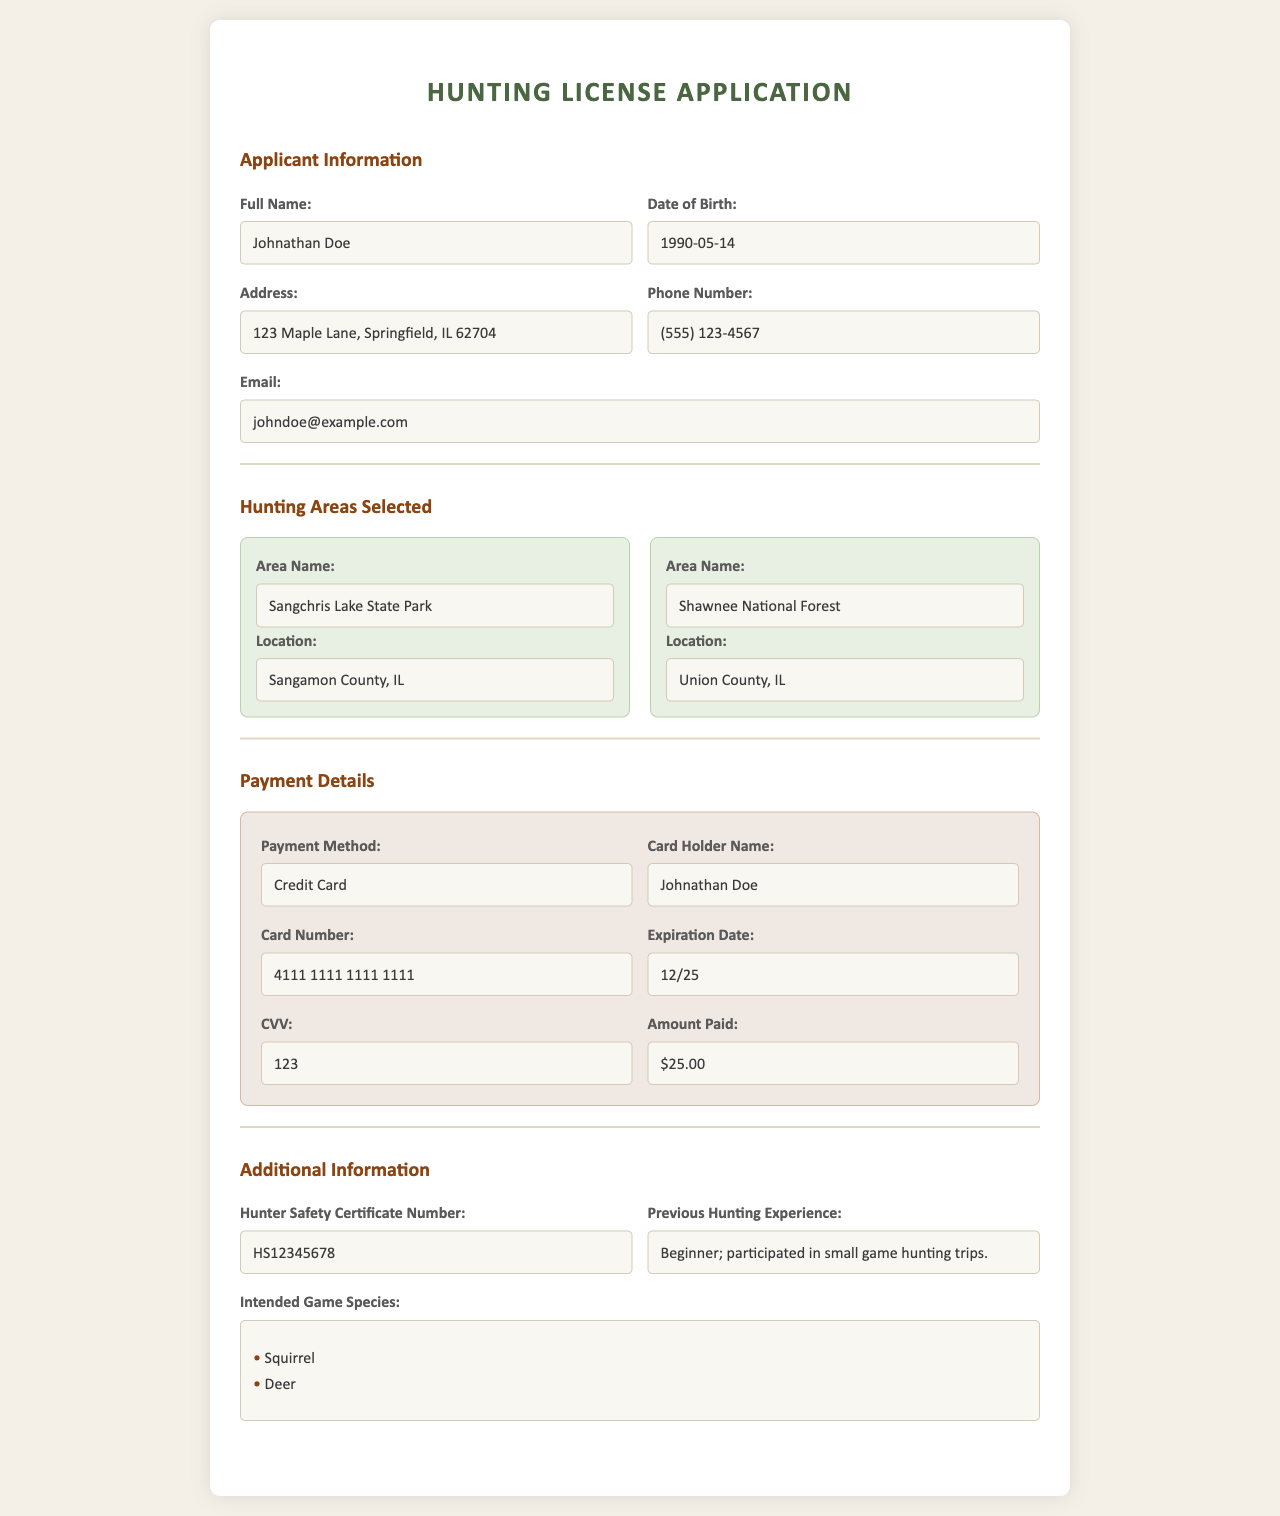What is the applicant's full name? The full name of the applicant is provided in the document under "Applicant Information."
Answer: Johnathan Doe What is the applicant's date of birth? The date of birth is specified in the "Applicant Information" section.
Answer: 1990-05-14 Which hunting area is located in Sangamon County? The document lists hunting areas selected along with their locations. Sangchris Lake State Park is in Sangamon County.
Answer: Sangchris Lake State Park What is the payment method used for this application? The payment method is mentioned in the "Payment Details" section of the document.
Answer: Credit Card What is the total amount paid for the hunting license? The amount paid is found in the "Amount Paid" section of the "Payment Details."
Answer: $25.00 How many game species are intended to be hunted? The number of intended game species can be counted from the "Intended Game Species" section.
Answer: 2 What is the Hunter Safety Certificate Number? The certificate number is provided in the "Additional Information" section of the document.
Answer: HS12345678 What previous experience does the applicant have in hunting? This information is detailed in the "Previous Hunting Experience" field of the document.
Answer: Beginner; participated in small game hunting trips Which area is located in Union County? The document lists the location of the hunting areas, revealing which one is in Union County.
Answer: Shawnee National Forest 